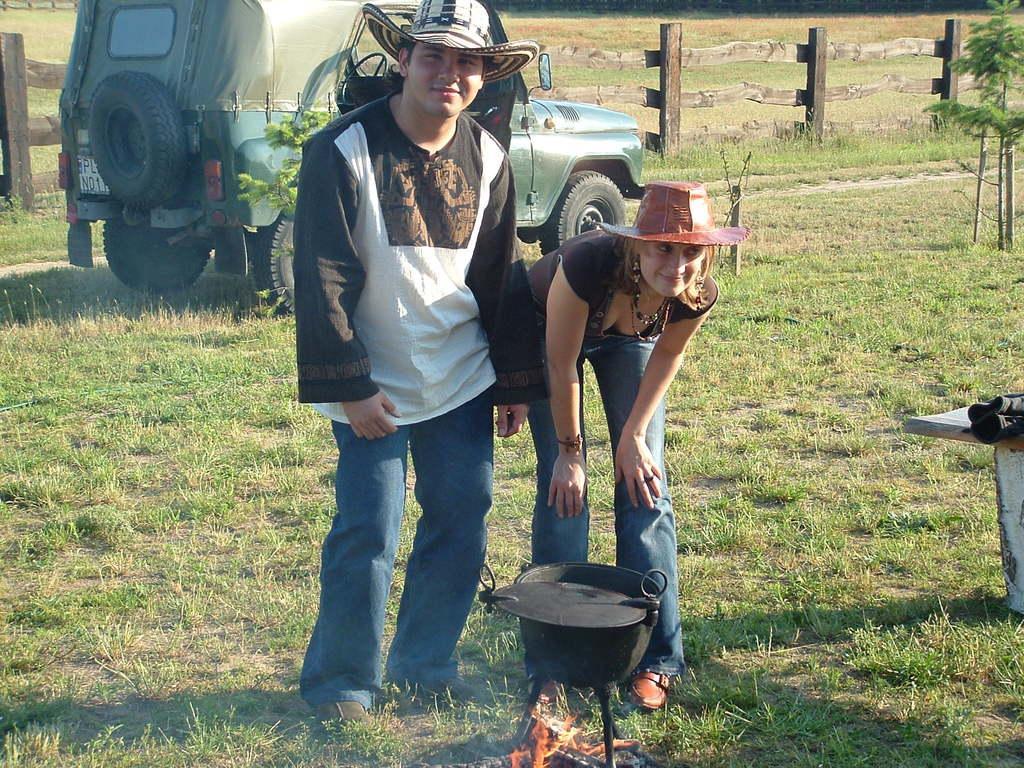Could you give a brief overview of what you see in this image? In this image we can see cooking on fire, persons standing on the ground, motor vehicle, wooden fence and plants. 